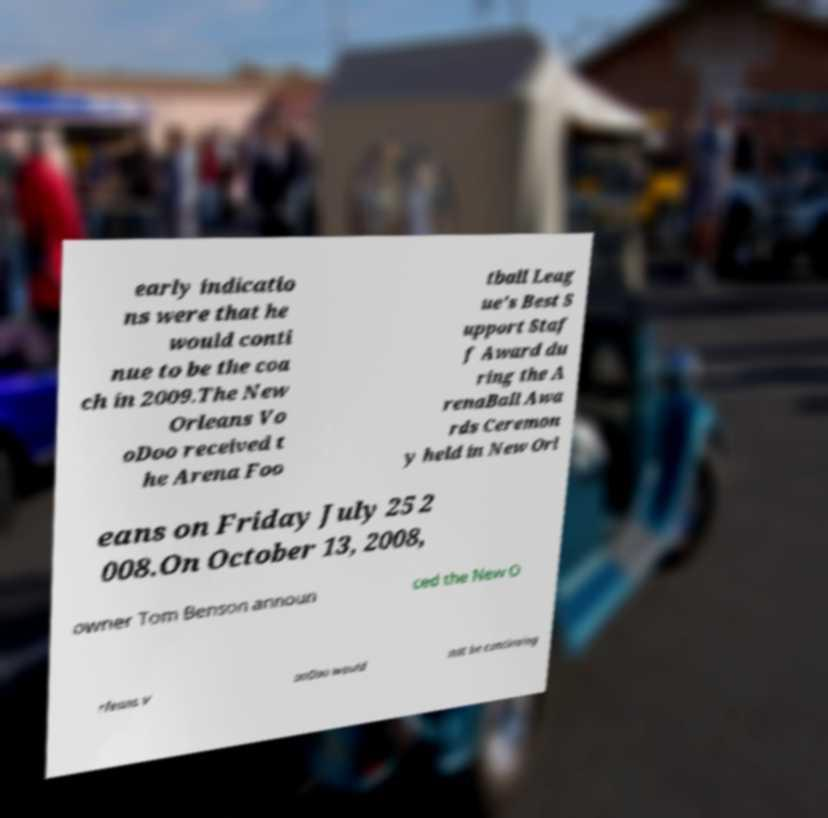What messages or text are displayed in this image? I need them in a readable, typed format. early indicatio ns were that he would conti nue to be the coa ch in 2009.The New Orleans Vo oDoo received t he Arena Foo tball Leag ue's Best S upport Staf f Award du ring the A renaBall Awa rds Ceremon y held in New Orl eans on Friday July 25 2 008.On October 13, 2008, owner Tom Benson announ ced the New O rleans V ooDoo would not be continuing 